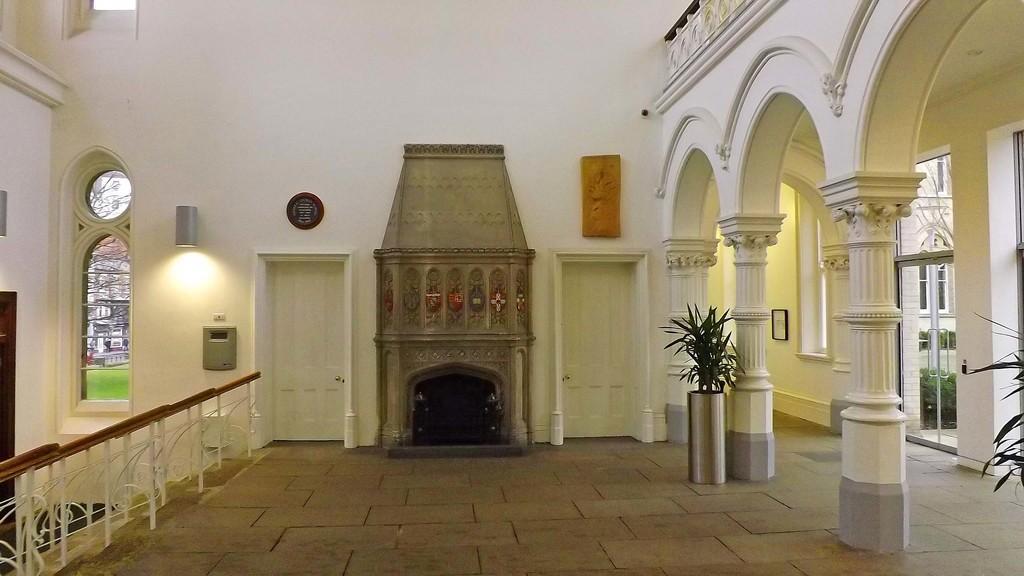How would you summarize this image in a sentence or two? In this image there is a staircase in the left corner. There is a potted plant, pillars with roofs and doors in the right corner. There is a floor at the bottom. There are doors, some frames on the wall and potted plant in the background. 